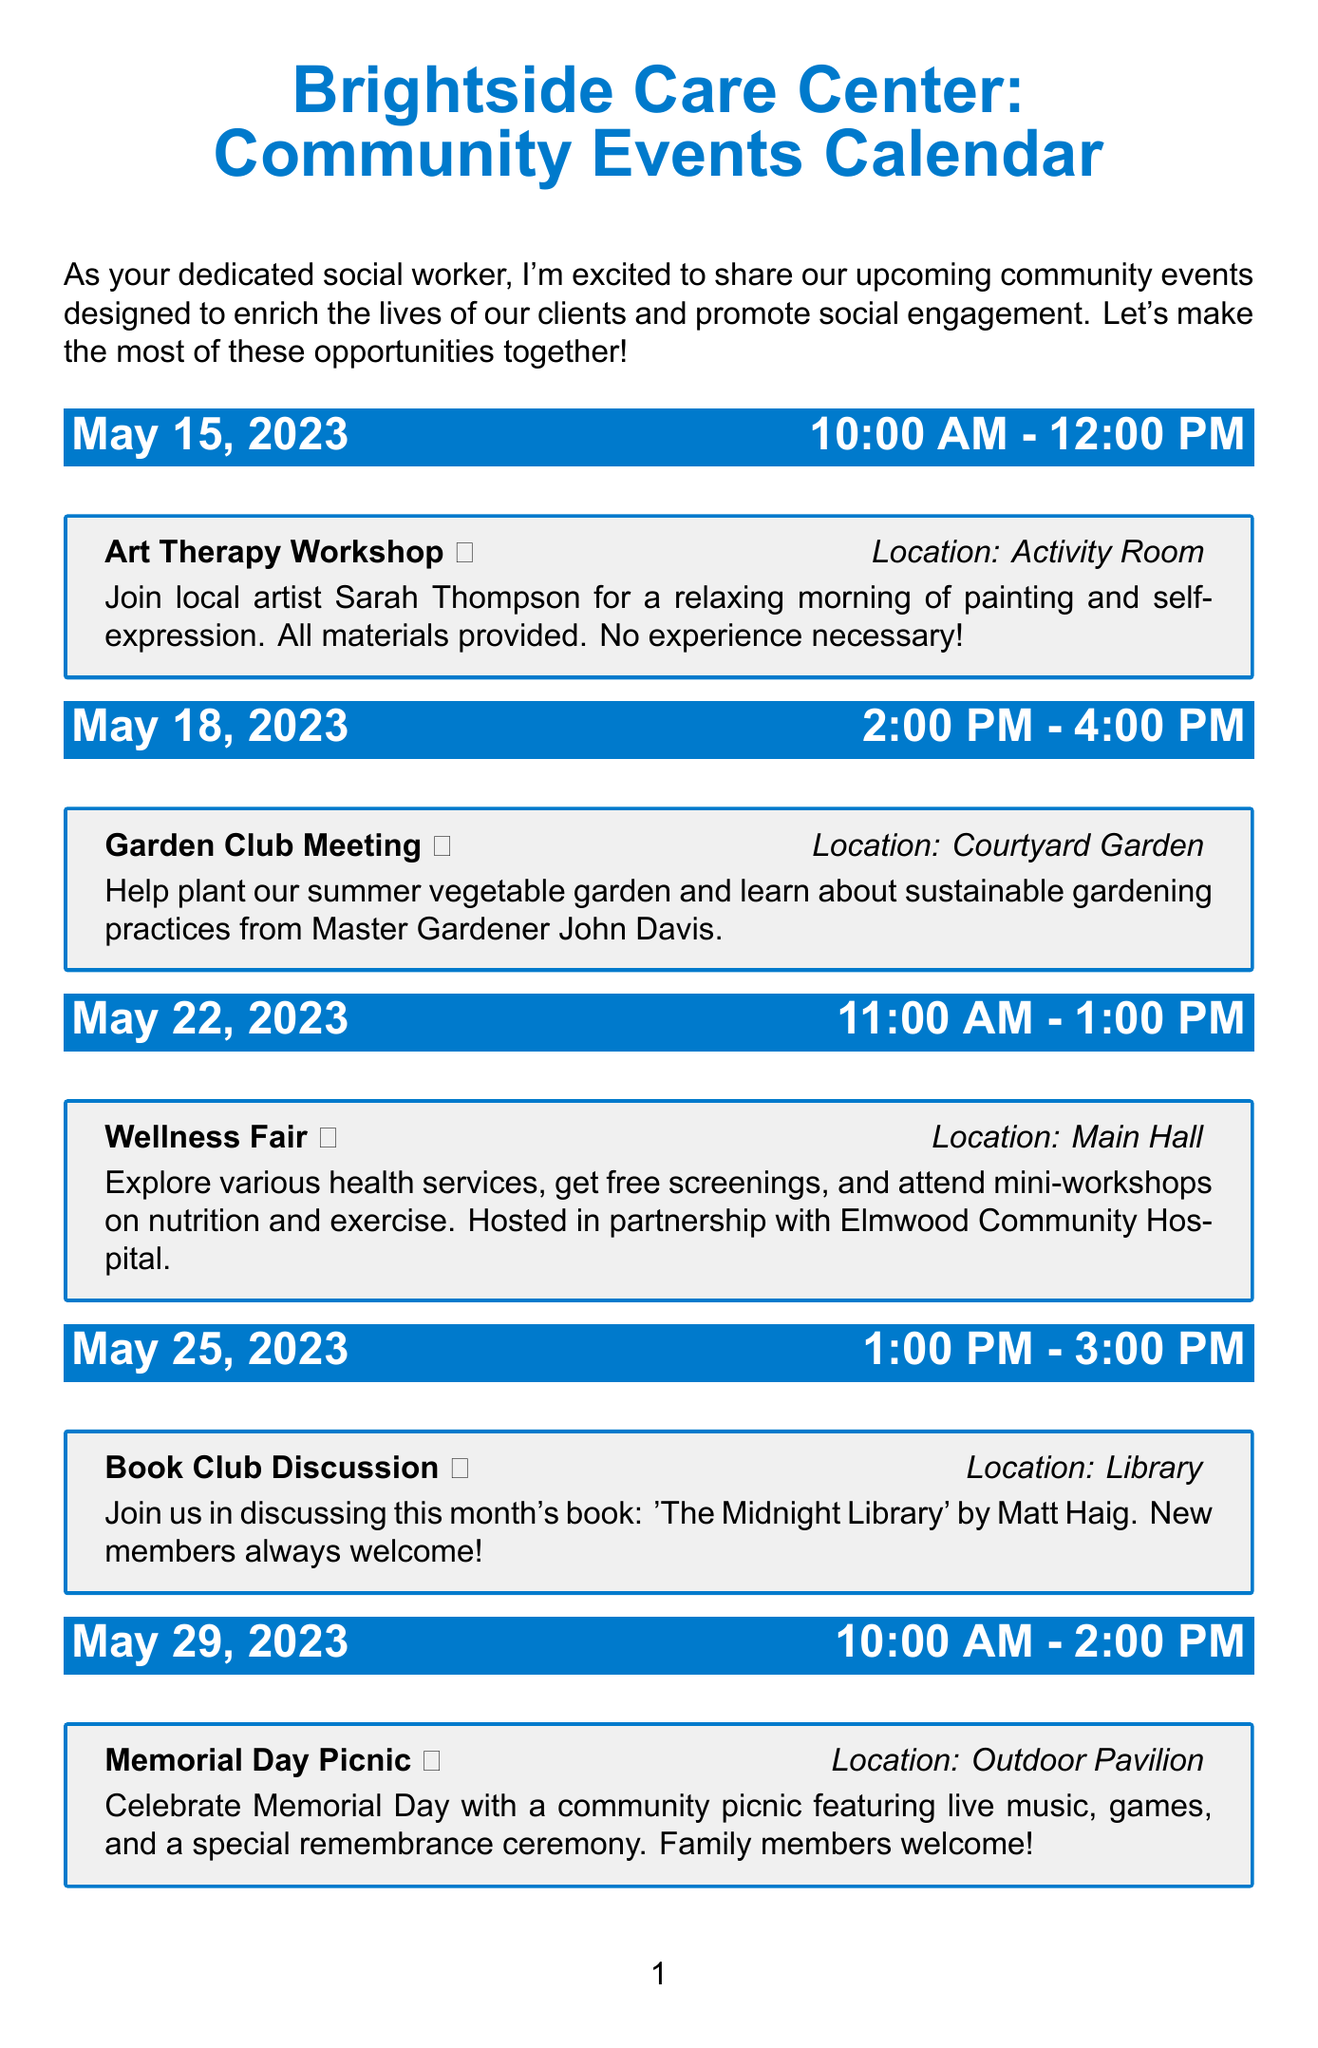what is the title of the newsletter? The title of the newsletter is found in the header section of the document.
Answer: Brightside Care Center: Community Events Calendar when is the Art Therapy Workshop scheduled? The date of the Art Therapy Workshop is specified in the events list.
Answer: May 15, 2023 where will the Garden Club Meeting take place? The location of the Garden Club Meeting is mentioned in the event details.
Answer: Courtyard Garden who is leading the Technology Workshop? The person leading the Technology Workshop is referenced in the event description.
Answer: Volunteers from Oakridge High School how long will the Wellness Fair last? The duration of the Wellness Fair can be calculated from the start and end times given in the document.
Answer: 2 hours what is the icon associated with the Book Club Discussion? Each event is represented by an icon, which is noted in the event details.
Answer: 📚 how many events are scheduled for May 2023? By counting the events listed for May, we find the total number of events for that month.
Answer: 5 what is the purpose of the Rights and Resources Workshop? The purpose of the Rights and Resources Workshop is indicated in its description.
Answer: Learn about your rights as a care facility resident is participation in the events mandatory? The footer note specifies the nature of participation in the events.
Answer: No 